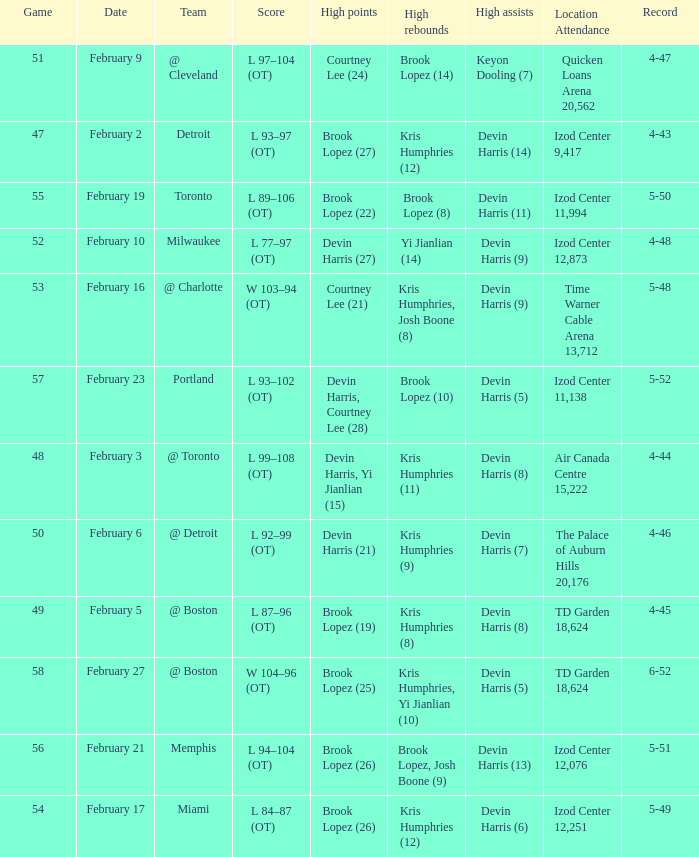What's the highest game number for a game in which Kris Humphries (8) did the high rebounds? 49.0. 